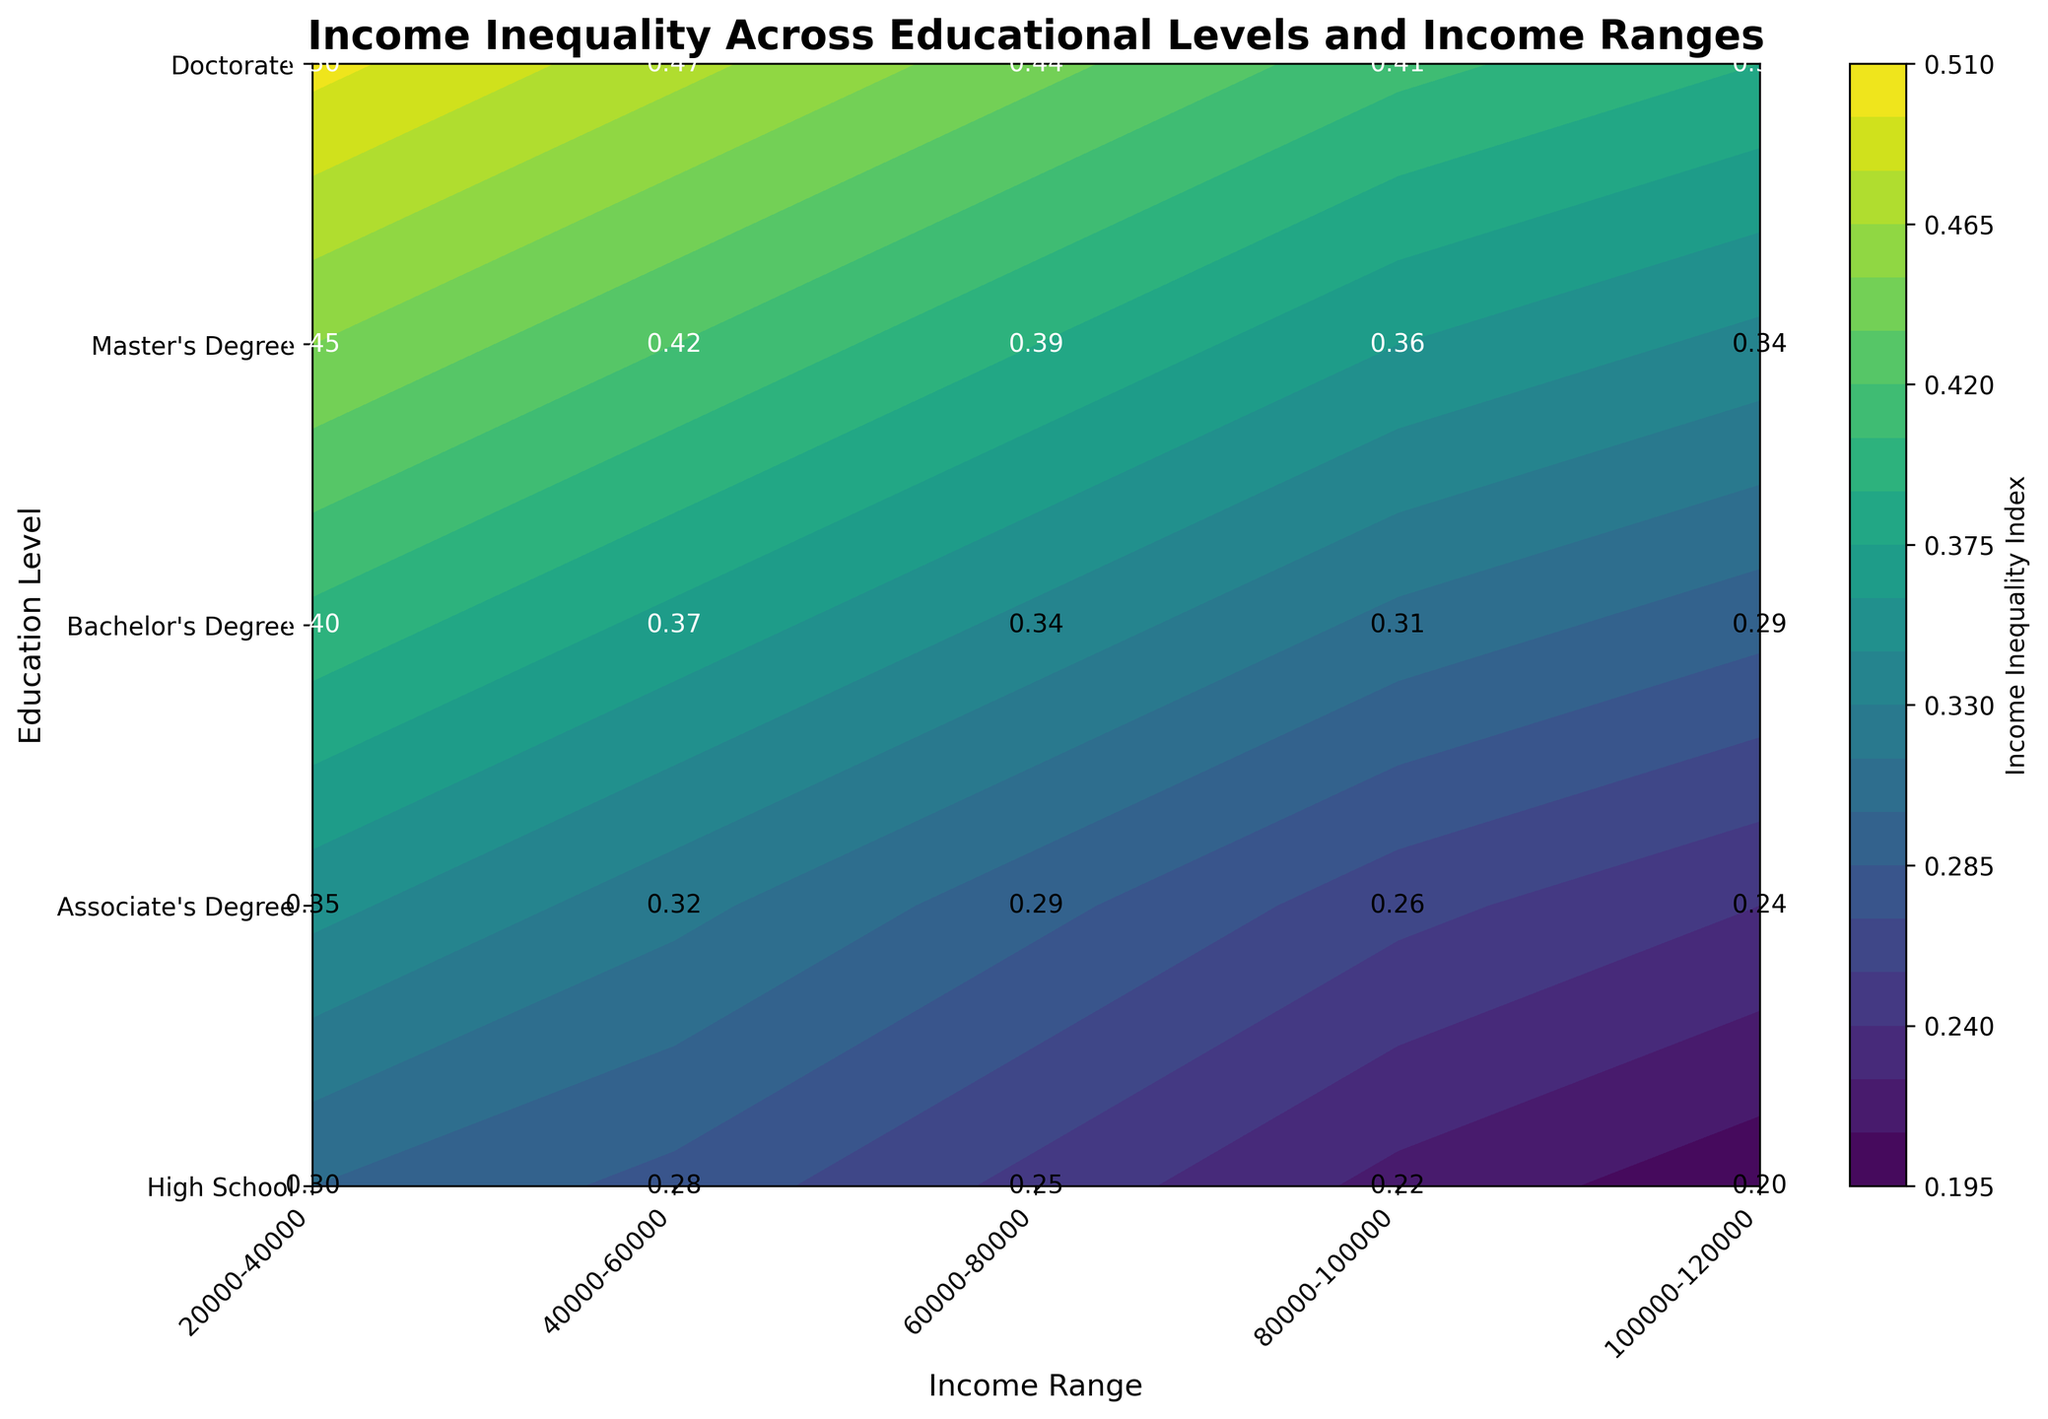What is the title of the figure? Look at the text displayed prominently at the top center of the figure.
Answer: Income Inequality Across Educational Levels and Income Ranges Which educational level has the highest income inequality index in the $100,000-$120,000 income range? Locate the y-axis representing educational levels and the x-axis representing income ranges. Find the intersection point for $100,000-$120,000 and compare the values.
Answer: Doctorate How does the income inequality index for a Bachelor's degree change as income ranges increase from $20,000-$40,000 to $100,000-$120,000? Follow the row corresponding to Bachelor’s degree and observe how the numerical values of the indices change from left to right.
Answer: It decreases from 0.4 to 0.29 Which income range shows the most uniform level of income inequality across different educational levels? Look at each column representing income ranges and examine the spread of values for different educational levels.
Answer: $100,000-$120,000 What is the overall trend in income inequality as income increases for people with a Master's degree? Trace the changes in values along the Master's degree row as you move from left to right on the plot.
Answer: It decreases from 0.45 to 0.34 How does the income inequality index for an Associate’s Degree compare to that of a High School diploma in the $60,000-$80,000 income range? Locate the $60,000-$80,000 column and compare the values for an Associate's Degree and a High School diploma.
Answer: Associate's Degree has a higher index (0.29 vs 0.25) Which education level shows the highest starting point of income inequality in the $20,000-$40,000 income range? Compare the values of all educational levels at the $20,000-$40,000 income range.
Answer: Doctorate What is the average income inequality index for High School graduates across all income ranges? Add all income inequality indices for High School graduates and divide by the number of data points.
Answer: (0.3 + 0.28 + 0.25 + 0.22 + 0.2) / 5 = 0.25 Do higher educational levels consistently show a lower income inequality index for higher income ranges? Compare the rows corresponding to higher educational levels (Bachelor’s, Master’s, Doctorate) and observe their value trends in higher income ranges.
Answer: Yes, generally In the $40,000-$60,000 income range, which educational level has the closest income inequality index to 0.3? Compare all values in the $40,000-$60,000 income column and identify the one closest to 0.3.
Answer: High School 